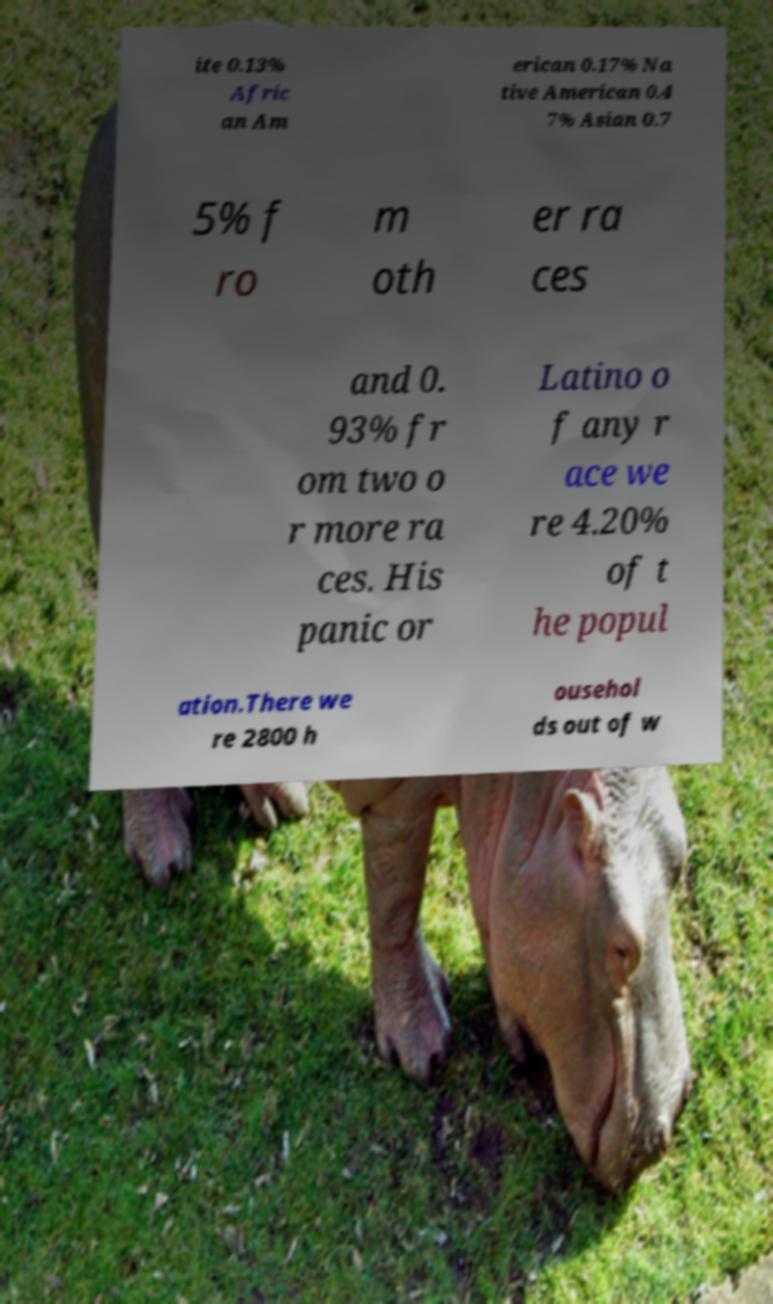Could you extract and type out the text from this image? ite 0.13% Afric an Am erican 0.17% Na tive American 0.4 7% Asian 0.7 5% f ro m oth er ra ces and 0. 93% fr om two o r more ra ces. His panic or Latino o f any r ace we re 4.20% of t he popul ation.There we re 2800 h ousehol ds out of w 